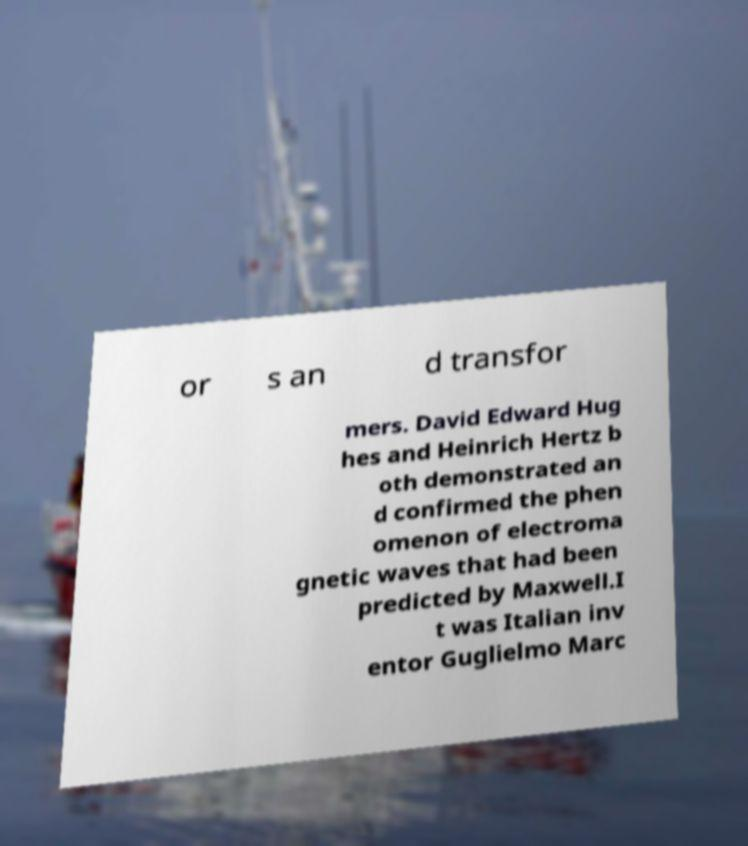For documentation purposes, I need the text within this image transcribed. Could you provide that? or s an d transfor mers. David Edward Hug hes and Heinrich Hertz b oth demonstrated an d confirmed the phen omenon of electroma gnetic waves that had been predicted by Maxwell.I t was Italian inv entor Guglielmo Marc 